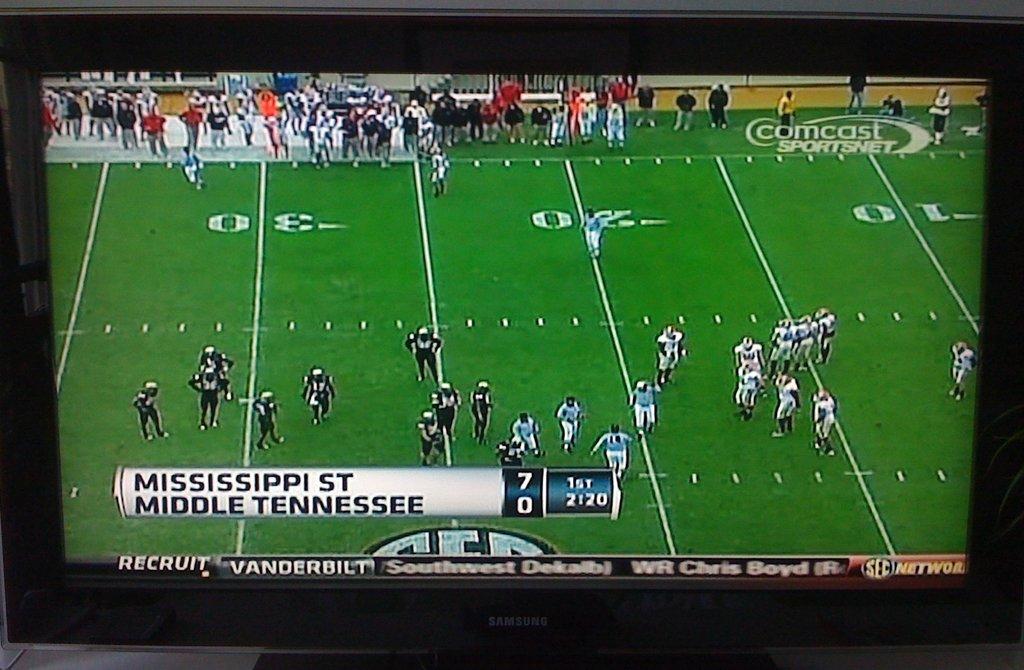What is the score?
Provide a short and direct response. 7-0. 